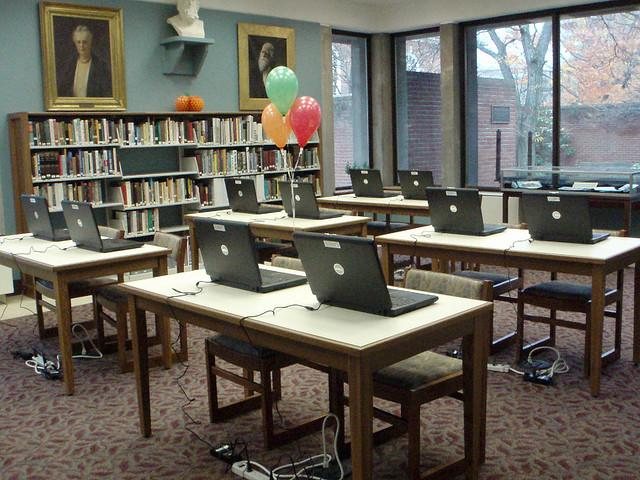What setting is this picture taken in? classroom 